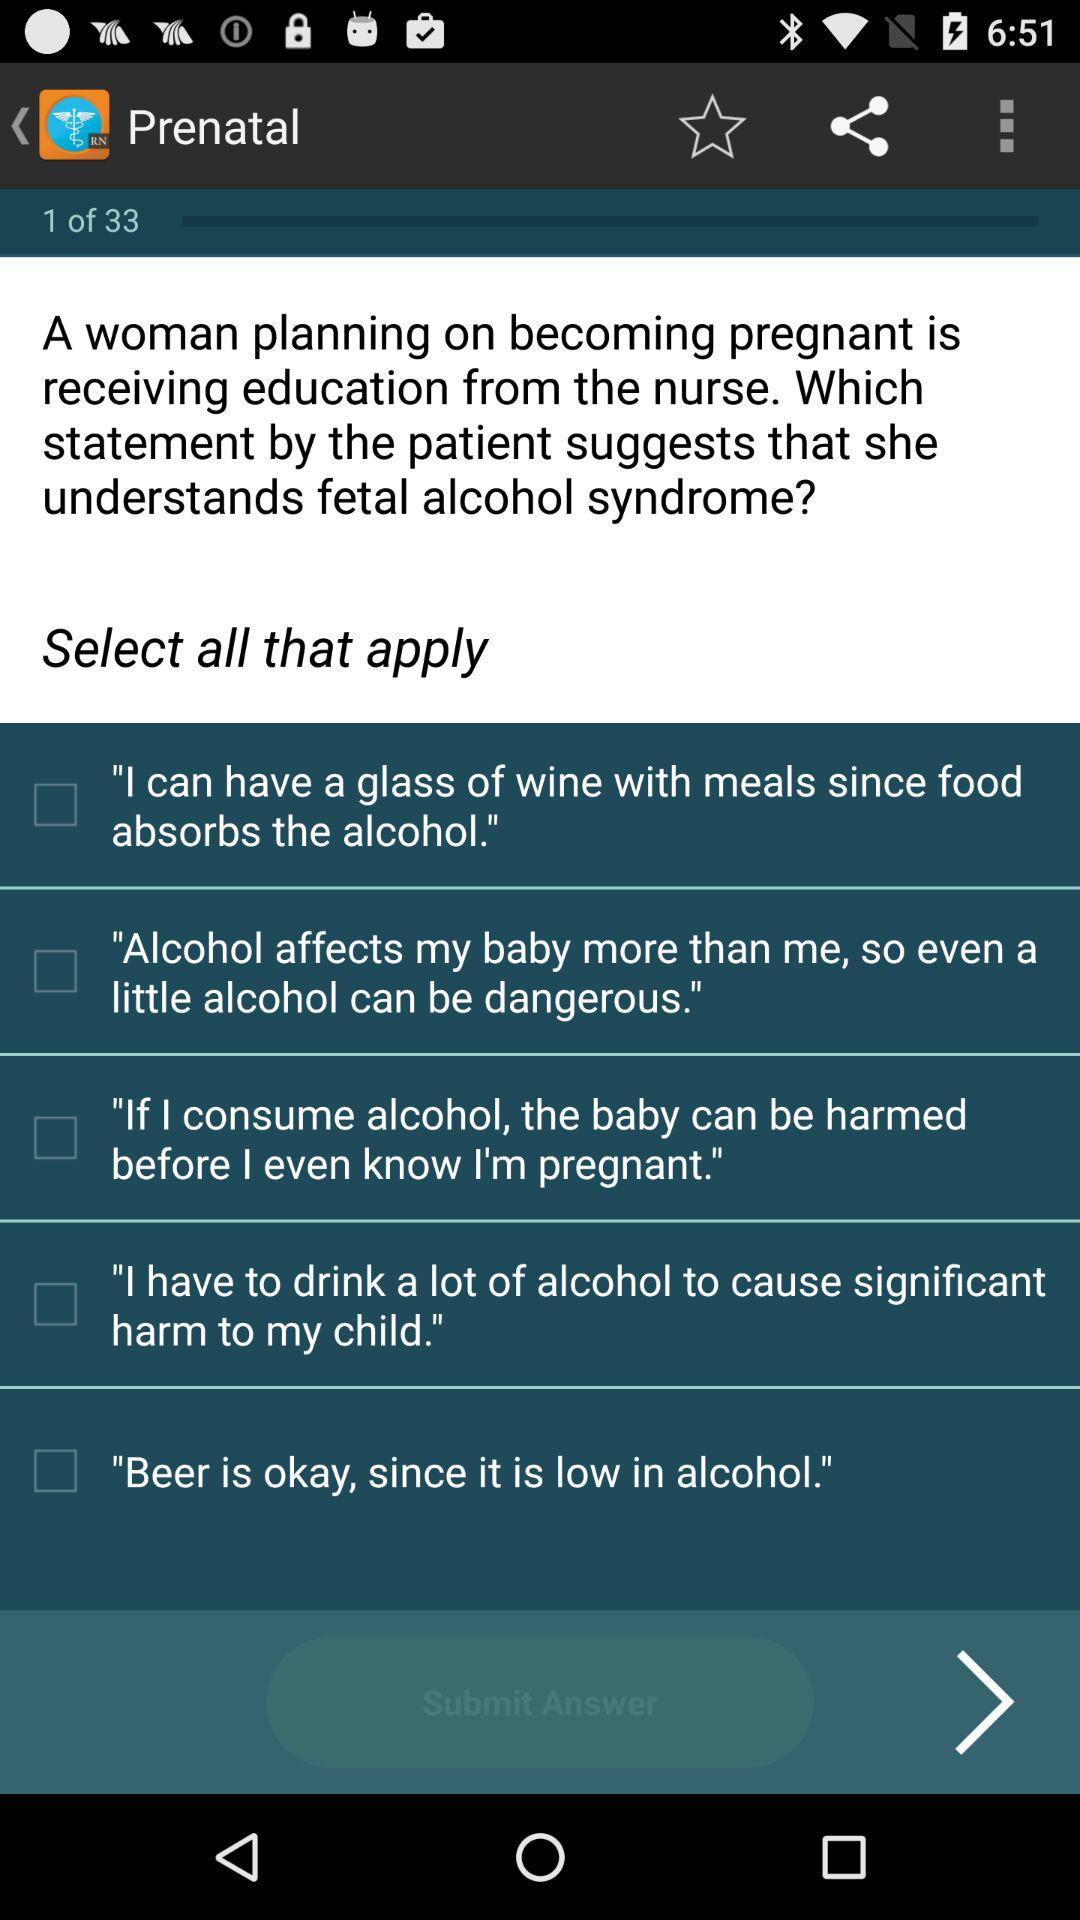How many question have been asked? There have been 33 questions asked. 